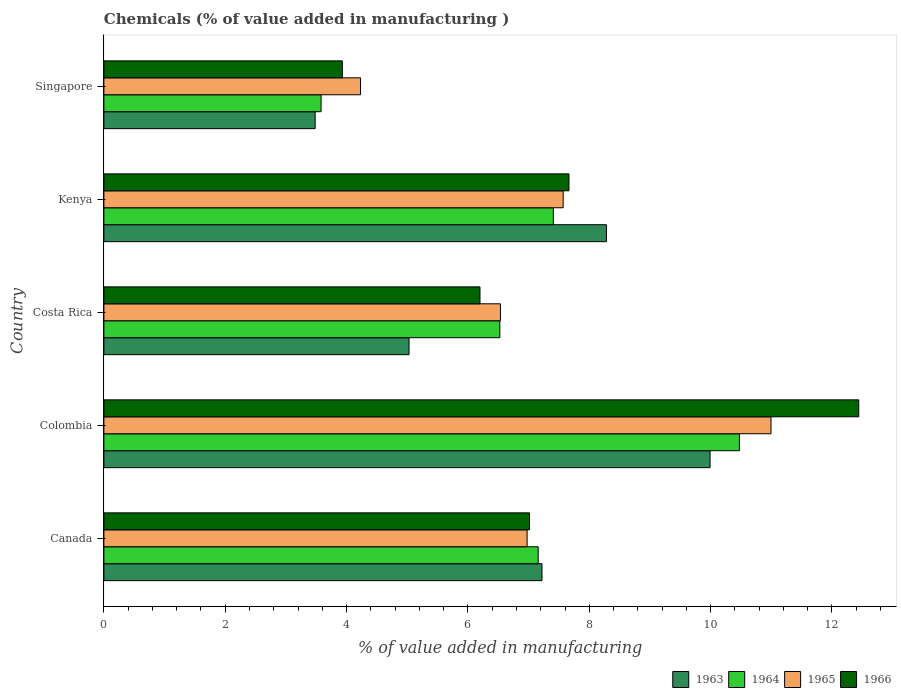Are the number of bars per tick equal to the number of legend labels?
Your response must be concise. Yes. What is the label of the 2nd group of bars from the top?
Give a very brief answer. Kenya. In how many cases, is the number of bars for a given country not equal to the number of legend labels?
Give a very brief answer. 0. What is the value added in manufacturing chemicals in 1966 in Singapore?
Offer a very short reply. 3.93. Across all countries, what is the maximum value added in manufacturing chemicals in 1966?
Provide a succinct answer. 12.44. Across all countries, what is the minimum value added in manufacturing chemicals in 1964?
Your answer should be very brief. 3.58. In which country was the value added in manufacturing chemicals in 1964 minimum?
Your response must be concise. Singapore. What is the total value added in manufacturing chemicals in 1963 in the graph?
Give a very brief answer. 34.01. What is the difference between the value added in manufacturing chemicals in 1963 in Canada and that in Kenya?
Offer a very short reply. -1.06. What is the difference between the value added in manufacturing chemicals in 1964 in Costa Rica and the value added in manufacturing chemicals in 1966 in Singapore?
Ensure brevity in your answer.  2.6. What is the average value added in manufacturing chemicals in 1965 per country?
Ensure brevity in your answer.  7.26. What is the difference between the value added in manufacturing chemicals in 1966 and value added in manufacturing chemicals in 1963 in Singapore?
Ensure brevity in your answer.  0.45. In how many countries, is the value added in manufacturing chemicals in 1963 greater than 6.8 %?
Offer a very short reply. 3. What is the ratio of the value added in manufacturing chemicals in 1964 in Canada to that in Colombia?
Offer a very short reply. 0.68. Is the difference between the value added in manufacturing chemicals in 1966 in Kenya and Singapore greater than the difference between the value added in manufacturing chemicals in 1963 in Kenya and Singapore?
Give a very brief answer. No. What is the difference between the highest and the second highest value added in manufacturing chemicals in 1965?
Your answer should be very brief. 3.43. What is the difference between the highest and the lowest value added in manufacturing chemicals in 1965?
Keep it short and to the point. 6.76. Is the sum of the value added in manufacturing chemicals in 1963 in Colombia and Singapore greater than the maximum value added in manufacturing chemicals in 1964 across all countries?
Give a very brief answer. Yes. Is it the case that in every country, the sum of the value added in manufacturing chemicals in 1965 and value added in manufacturing chemicals in 1966 is greater than the sum of value added in manufacturing chemicals in 1964 and value added in manufacturing chemicals in 1963?
Provide a short and direct response. No. What does the 4th bar from the top in Kenya represents?
Make the answer very short. 1963. What does the 4th bar from the bottom in Costa Rica represents?
Provide a short and direct response. 1966. How many bars are there?
Your answer should be compact. 20. Does the graph contain any zero values?
Provide a short and direct response. No. Does the graph contain grids?
Give a very brief answer. No. What is the title of the graph?
Offer a terse response. Chemicals (% of value added in manufacturing ). Does "2003" appear as one of the legend labels in the graph?
Keep it short and to the point. No. What is the label or title of the X-axis?
Offer a terse response. % of value added in manufacturing. What is the % of value added in manufacturing in 1963 in Canada?
Provide a short and direct response. 7.22. What is the % of value added in manufacturing of 1964 in Canada?
Ensure brevity in your answer.  7.16. What is the % of value added in manufacturing in 1965 in Canada?
Your response must be concise. 6.98. What is the % of value added in manufacturing in 1966 in Canada?
Make the answer very short. 7.01. What is the % of value added in manufacturing of 1963 in Colombia?
Give a very brief answer. 9.99. What is the % of value added in manufacturing of 1964 in Colombia?
Your answer should be compact. 10.47. What is the % of value added in manufacturing of 1965 in Colombia?
Your answer should be compact. 10.99. What is the % of value added in manufacturing in 1966 in Colombia?
Keep it short and to the point. 12.44. What is the % of value added in manufacturing in 1963 in Costa Rica?
Your response must be concise. 5.03. What is the % of value added in manufacturing in 1964 in Costa Rica?
Provide a short and direct response. 6.53. What is the % of value added in manufacturing in 1965 in Costa Rica?
Provide a short and direct response. 6.54. What is the % of value added in manufacturing in 1966 in Costa Rica?
Make the answer very short. 6.2. What is the % of value added in manufacturing of 1963 in Kenya?
Give a very brief answer. 8.28. What is the % of value added in manufacturing of 1964 in Kenya?
Make the answer very short. 7.41. What is the % of value added in manufacturing in 1965 in Kenya?
Your answer should be very brief. 7.57. What is the % of value added in manufacturing in 1966 in Kenya?
Make the answer very short. 7.67. What is the % of value added in manufacturing in 1963 in Singapore?
Ensure brevity in your answer.  3.48. What is the % of value added in manufacturing of 1964 in Singapore?
Provide a succinct answer. 3.58. What is the % of value added in manufacturing of 1965 in Singapore?
Give a very brief answer. 4.23. What is the % of value added in manufacturing of 1966 in Singapore?
Make the answer very short. 3.93. Across all countries, what is the maximum % of value added in manufacturing in 1963?
Provide a succinct answer. 9.99. Across all countries, what is the maximum % of value added in manufacturing of 1964?
Give a very brief answer. 10.47. Across all countries, what is the maximum % of value added in manufacturing of 1965?
Provide a succinct answer. 10.99. Across all countries, what is the maximum % of value added in manufacturing of 1966?
Provide a succinct answer. 12.44. Across all countries, what is the minimum % of value added in manufacturing of 1963?
Provide a short and direct response. 3.48. Across all countries, what is the minimum % of value added in manufacturing of 1964?
Provide a succinct answer. 3.58. Across all countries, what is the minimum % of value added in manufacturing of 1965?
Provide a succinct answer. 4.23. Across all countries, what is the minimum % of value added in manufacturing of 1966?
Provide a succinct answer. 3.93. What is the total % of value added in manufacturing in 1963 in the graph?
Keep it short and to the point. 34.01. What is the total % of value added in manufacturing in 1964 in the graph?
Give a very brief answer. 35.15. What is the total % of value added in manufacturing in 1965 in the graph?
Offer a terse response. 36.31. What is the total % of value added in manufacturing of 1966 in the graph?
Keep it short and to the point. 37.25. What is the difference between the % of value added in manufacturing in 1963 in Canada and that in Colombia?
Provide a succinct answer. -2.77. What is the difference between the % of value added in manufacturing of 1964 in Canada and that in Colombia?
Ensure brevity in your answer.  -3.32. What is the difference between the % of value added in manufacturing of 1965 in Canada and that in Colombia?
Provide a succinct answer. -4.02. What is the difference between the % of value added in manufacturing of 1966 in Canada and that in Colombia?
Your answer should be compact. -5.43. What is the difference between the % of value added in manufacturing of 1963 in Canada and that in Costa Rica?
Provide a short and direct response. 2.19. What is the difference between the % of value added in manufacturing of 1964 in Canada and that in Costa Rica?
Give a very brief answer. 0.63. What is the difference between the % of value added in manufacturing of 1965 in Canada and that in Costa Rica?
Keep it short and to the point. 0.44. What is the difference between the % of value added in manufacturing in 1966 in Canada and that in Costa Rica?
Offer a terse response. 0.82. What is the difference between the % of value added in manufacturing of 1963 in Canada and that in Kenya?
Make the answer very short. -1.06. What is the difference between the % of value added in manufacturing in 1964 in Canada and that in Kenya?
Provide a short and direct response. -0.25. What is the difference between the % of value added in manufacturing in 1965 in Canada and that in Kenya?
Ensure brevity in your answer.  -0.59. What is the difference between the % of value added in manufacturing of 1966 in Canada and that in Kenya?
Your response must be concise. -0.65. What is the difference between the % of value added in manufacturing of 1963 in Canada and that in Singapore?
Provide a succinct answer. 3.74. What is the difference between the % of value added in manufacturing of 1964 in Canada and that in Singapore?
Give a very brief answer. 3.58. What is the difference between the % of value added in manufacturing of 1965 in Canada and that in Singapore?
Make the answer very short. 2.75. What is the difference between the % of value added in manufacturing in 1966 in Canada and that in Singapore?
Your answer should be very brief. 3.08. What is the difference between the % of value added in manufacturing in 1963 in Colombia and that in Costa Rica?
Make the answer very short. 4.96. What is the difference between the % of value added in manufacturing of 1964 in Colombia and that in Costa Rica?
Your response must be concise. 3.95. What is the difference between the % of value added in manufacturing in 1965 in Colombia and that in Costa Rica?
Ensure brevity in your answer.  4.46. What is the difference between the % of value added in manufacturing of 1966 in Colombia and that in Costa Rica?
Offer a very short reply. 6.24. What is the difference between the % of value added in manufacturing of 1963 in Colombia and that in Kenya?
Your answer should be compact. 1.71. What is the difference between the % of value added in manufacturing in 1964 in Colombia and that in Kenya?
Provide a short and direct response. 3.07. What is the difference between the % of value added in manufacturing of 1965 in Colombia and that in Kenya?
Make the answer very short. 3.43. What is the difference between the % of value added in manufacturing of 1966 in Colombia and that in Kenya?
Offer a very short reply. 4.78. What is the difference between the % of value added in manufacturing in 1963 in Colombia and that in Singapore?
Offer a terse response. 6.51. What is the difference between the % of value added in manufacturing in 1964 in Colombia and that in Singapore?
Give a very brief answer. 6.89. What is the difference between the % of value added in manufacturing of 1965 in Colombia and that in Singapore?
Provide a succinct answer. 6.76. What is the difference between the % of value added in manufacturing of 1966 in Colombia and that in Singapore?
Provide a succinct answer. 8.51. What is the difference between the % of value added in manufacturing in 1963 in Costa Rica and that in Kenya?
Give a very brief answer. -3.25. What is the difference between the % of value added in manufacturing in 1964 in Costa Rica and that in Kenya?
Provide a succinct answer. -0.88. What is the difference between the % of value added in manufacturing of 1965 in Costa Rica and that in Kenya?
Provide a short and direct response. -1.03. What is the difference between the % of value added in manufacturing in 1966 in Costa Rica and that in Kenya?
Give a very brief answer. -1.47. What is the difference between the % of value added in manufacturing in 1963 in Costa Rica and that in Singapore?
Ensure brevity in your answer.  1.55. What is the difference between the % of value added in manufacturing of 1964 in Costa Rica and that in Singapore?
Provide a short and direct response. 2.95. What is the difference between the % of value added in manufacturing in 1965 in Costa Rica and that in Singapore?
Ensure brevity in your answer.  2.31. What is the difference between the % of value added in manufacturing in 1966 in Costa Rica and that in Singapore?
Keep it short and to the point. 2.27. What is the difference between the % of value added in manufacturing of 1963 in Kenya and that in Singapore?
Ensure brevity in your answer.  4.8. What is the difference between the % of value added in manufacturing in 1964 in Kenya and that in Singapore?
Offer a terse response. 3.83. What is the difference between the % of value added in manufacturing in 1965 in Kenya and that in Singapore?
Offer a terse response. 3.34. What is the difference between the % of value added in manufacturing of 1966 in Kenya and that in Singapore?
Make the answer very short. 3.74. What is the difference between the % of value added in manufacturing in 1963 in Canada and the % of value added in manufacturing in 1964 in Colombia?
Keep it short and to the point. -3.25. What is the difference between the % of value added in manufacturing of 1963 in Canada and the % of value added in manufacturing of 1965 in Colombia?
Offer a very short reply. -3.77. What is the difference between the % of value added in manufacturing in 1963 in Canada and the % of value added in manufacturing in 1966 in Colombia?
Your response must be concise. -5.22. What is the difference between the % of value added in manufacturing of 1964 in Canada and the % of value added in manufacturing of 1965 in Colombia?
Keep it short and to the point. -3.84. What is the difference between the % of value added in manufacturing in 1964 in Canada and the % of value added in manufacturing in 1966 in Colombia?
Your response must be concise. -5.28. What is the difference between the % of value added in manufacturing of 1965 in Canada and the % of value added in manufacturing of 1966 in Colombia?
Keep it short and to the point. -5.47. What is the difference between the % of value added in manufacturing of 1963 in Canada and the % of value added in manufacturing of 1964 in Costa Rica?
Your answer should be compact. 0.69. What is the difference between the % of value added in manufacturing in 1963 in Canada and the % of value added in manufacturing in 1965 in Costa Rica?
Your answer should be very brief. 0.68. What is the difference between the % of value added in manufacturing of 1963 in Canada and the % of value added in manufacturing of 1966 in Costa Rica?
Your answer should be very brief. 1.02. What is the difference between the % of value added in manufacturing in 1964 in Canada and the % of value added in manufacturing in 1965 in Costa Rica?
Your answer should be very brief. 0.62. What is the difference between the % of value added in manufacturing in 1964 in Canada and the % of value added in manufacturing in 1966 in Costa Rica?
Offer a very short reply. 0.96. What is the difference between the % of value added in manufacturing in 1965 in Canada and the % of value added in manufacturing in 1966 in Costa Rica?
Offer a very short reply. 0.78. What is the difference between the % of value added in manufacturing of 1963 in Canada and the % of value added in manufacturing of 1964 in Kenya?
Provide a succinct answer. -0.19. What is the difference between the % of value added in manufacturing in 1963 in Canada and the % of value added in manufacturing in 1965 in Kenya?
Offer a terse response. -0.35. What is the difference between the % of value added in manufacturing in 1963 in Canada and the % of value added in manufacturing in 1966 in Kenya?
Offer a very short reply. -0.44. What is the difference between the % of value added in manufacturing in 1964 in Canada and the % of value added in manufacturing in 1965 in Kenya?
Give a very brief answer. -0.41. What is the difference between the % of value added in manufacturing in 1964 in Canada and the % of value added in manufacturing in 1966 in Kenya?
Ensure brevity in your answer.  -0.51. What is the difference between the % of value added in manufacturing of 1965 in Canada and the % of value added in manufacturing of 1966 in Kenya?
Keep it short and to the point. -0.69. What is the difference between the % of value added in manufacturing of 1963 in Canada and the % of value added in manufacturing of 1964 in Singapore?
Offer a terse response. 3.64. What is the difference between the % of value added in manufacturing of 1963 in Canada and the % of value added in manufacturing of 1965 in Singapore?
Your answer should be very brief. 2.99. What is the difference between the % of value added in manufacturing in 1963 in Canada and the % of value added in manufacturing in 1966 in Singapore?
Provide a succinct answer. 3.29. What is the difference between the % of value added in manufacturing in 1964 in Canada and the % of value added in manufacturing in 1965 in Singapore?
Give a very brief answer. 2.93. What is the difference between the % of value added in manufacturing in 1964 in Canada and the % of value added in manufacturing in 1966 in Singapore?
Provide a short and direct response. 3.23. What is the difference between the % of value added in manufacturing of 1965 in Canada and the % of value added in manufacturing of 1966 in Singapore?
Provide a succinct answer. 3.05. What is the difference between the % of value added in manufacturing of 1963 in Colombia and the % of value added in manufacturing of 1964 in Costa Rica?
Your answer should be compact. 3.47. What is the difference between the % of value added in manufacturing of 1963 in Colombia and the % of value added in manufacturing of 1965 in Costa Rica?
Provide a succinct answer. 3.46. What is the difference between the % of value added in manufacturing in 1963 in Colombia and the % of value added in manufacturing in 1966 in Costa Rica?
Offer a terse response. 3.79. What is the difference between the % of value added in manufacturing of 1964 in Colombia and the % of value added in manufacturing of 1965 in Costa Rica?
Give a very brief answer. 3.94. What is the difference between the % of value added in manufacturing in 1964 in Colombia and the % of value added in manufacturing in 1966 in Costa Rica?
Make the answer very short. 4.28. What is the difference between the % of value added in manufacturing of 1965 in Colombia and the % of value added in manufacturing of 1966 in Costa Rica?
Keep it short and to the point. 4.8. What is the difference between the % of value added in manufacturing of 1963 in Colombia and the % of value added in manufacturing of 1964 in Kenya?
Your answer should be very brief. 2.58. What is the difference between the % of value added in manufacturing of 1963 in Colombia and the % of value added in manufacturing of 1965 in Kenya?
Your answer should be compact. 2.42. What is the difference between the % of value added in manufacturing in 1963 in Colombia and the % of value added in manufacturing in 1966 in Kenya?
Your answer should be very brief. 2.33. What is the difference between the % of value added in manufacturing in 1964 in Colombia and the % of value added in manufacturing in 1965 in Kenya?
Give a very brief answer. 2.9. What is the difference between the % of value added in manufacturing of 1964 in Colombia and the % of value added in manufacturing of 1966 in Kenya?
Provide a succinct answer. 2.81. What is the difference between the % of value added in manufacturing in 1965 in Colombia and the % of value added in manufacturing in 1966 in Kenya?
Offer a terse response. 3.33. What is the difference between the % of value added in manufacturing in 1963 in Colombia and the % of value added in manufacturing in 1964 in Singapore?
Provide a short and direct response. 6.41. What is the difference between the % of value added in manufacturing of 1963 in Colombia and the % of value added in manufacturing of 1965 in Singapore?
Your response must be concise. 5.76. What is the difference between the % of value added in manufacturing in 1963 in Colombia and the % of value added in manufacturing in 1966 in Singapore?
Your answer should be very brief. 6.06. What is the difference between the % of value added in manufacturing of 1964 in Colombia and the % of value added in manufacturing of 1965 in Singapore?
Your answer should be compact. 6.24. What is the difference between the % of value added in manufacturing in 1964 in Colombia and the % of value added in manufacturing in 1966 in Singapore?
Provide a succinct answer. 6.54. What is the difference between the % of value added in manufacturing of 1965 in Colombia and the % of value added in manufacturing of 1966 in Singapore?
Your response must be concise. 7.07. What is the difference between the % of value added in manufacturing of 1963 in Costa Rica and the % of value added in manufacturing of 1964 in Kenya?
Ensure brevity in your answer.  -2.38. What is the difference between the % of value added in manufacturing in 1963 in Costa Rica and the % of value added in manufacturing in 1965 in Kenya?
Make the answer very short. -2.54. What is the difference between the % of value added in manufacturing of 1963 in Costa Rica and the % of value added in manufacturing of 1966 in Kenya?
Your response must be concise. -2.64. What is the difference between the % of value added in manufacturing in 1964 in Costa Rica and the % of value added in manufacturing in 1965 in Kenya?
Ensure brevity in your answer.  -1.04. What is the difference between the % of value added in manufacturing in 1964 in Costa Rica and the % of value added in manufacturing in 1966 in Kenya?
Offer a terse response. -1.14. What is the difference between the % of value added in manufacturing in 1965 in Costa Rica and the % of value added in manufacturing in 1966 in Kenya?
Provide a short and direct response. -1.13. What is the difference between the % of value added in manufacturing in 1963 in Costa Rica and the % of value added in manufacturing in 1964 in Singapore?
Make the answer very short. 1.45. What is the difference between the % of value added in manufacturing of 1963 in Costa Rica and the % of value added in manufacturing of 1965 in Singapore?
Your response must be concise. 0.8. What is the difference between the % of value added in manufacturing in 1963 in Costa Rica and the % of value added in manufacturing in 1966 in Singapore?
Ensure brevity in your answer.  1.1. What is the difference between the % of value added in manufacturing of 1964 in Costa Rica and the % of value added in manufacturing of 1965 in Singapore?
Offer a very short reply. 2.3. What is the difference between the % of value added in manufacturing in 1964 in Costa Rica and the % of value added in manufacturing in 1966 in Singapore?
Your response must be concise. 2.6. What is the difference between the % of value added in manufacturing of 1965 in Costa Rica and the % of value added in manufacturing of 1966 in Singapore?
Offer a very short reply. 2.61. What is the difference between the % of value added in manufacturing of 1963 in Kenya and the % of value added in manufacturing of 1964 in Singapore?
Ensure brevity in your answer.  4.7. What is the difference between the % of value added in manufacturing in 1963 in Kenya and the % of value added in manufacturing in 1965 in Singapore?
Offer a very short reply. 4.05. What is the difference between the % of value added in manufacturing of 1963 in Kenya and the % of value added in manufacturing of 1966 in Singapore?
Give a very brief answer. 4.35. What is the difference between the % of value added in manufacturing in 1964 in Kenya and the % of value added in manufacturing in 1965 in Singapore?
Your answer should be very brief. 3.18. What is the difference between the % of value added in manufacturing of 1964 in Kenya and the % of value added in manufacturing of 1966 in Singapore?
Make the answer very short. 3.48. What is the difference between the % of value added in manufacturing of 1965 in Kenya and the % of value added in manufacturing of 1966 in Singapore?
Provide a short and direct response. 3.64. What is the average % of value added in manufacturing of 1963 per country?
Make the answer very short. 6.8. What is the average % of value added in manufacturing in 1964 per country?
Your answer should be very brief. 7.03. What is the average % of value added in manufacturing of 1965 per country?
Ensure brevity in your answer.  7.26. What is the average % of value added in manufacturing of 1966 per country?
Your response must be concise. 7.45. What is the difference between the % of value added in manufacturing of 1963 and % of value added in manufacturing of 1964 in Canada?
Give a very brief answer. 0.06. What is the difference between the % of value added in manufacturing in 1963 and % of value added in manufacturing in 1965 in Canada?
Keep it short and to the point. 0.25. What is the difference between the % of value added in manufacturing of 1963 and % of value added in manufacturing of 1966 in Canada?
Provide a succinct answer. 0.21. What is the difference between the % of value added in manufacturing in 1964 and % of value added in manufacturing in 1965 in Canada?
Give a very brief answer. 0.18. What is the difference between the % of value added in manufacturing in 1964 and % of value added in manufacturing in 1966 in Canada?
Your answer should be compact. 0.14. What is the difference between the % of value added in manufacturing in 1965 and % of value added in manufacturing in 1966 in Canada?
Offer a very short reply. -0.04. What is the difference between the % of value added in manufacturing of 1963 and % of value added in manufacturing of 1964 in Colombia?
Provide a succinct answer. -0.48. What is the difference between the % of value added in manufacturing of 1963 and % of value added in manufacturing of 1965 in Colombia?
Keep it short and to the point. -1. What is the difference between the % of value added in manufacturing in 1963 and % of value added in manufacturing in 1966 in Colombia?
Your answer should be very brief. -2.45. What is the difference between the % of value added in manufacturing in 1964 and % of value added in manufacturing in 1965 in Colombia?
Offer a terse response. -0.52. What is the difference between the % of value added in manufacturing of 1964 and % of value added in manufacturing of 1966 in Colombia?
Provide a succinct answer. -1.97. What is the difference between the % of value added in manufacturing in 1965 and % of value added in manufacturing in 1966 in Colombia?
Offer a terse response. -1.45. What is the difference between the % of value added in manufacturing in 1963 and % of value added in manufacturing in 1964 in Costa Rica?
Your response must be concise. -1.5. What is the difference between the % of value added in manufacturing of 1963 and % of value added in manufacturing of 1965 in Costa Rica?
Offer a very short reply. -1.51. What is the difference between the % of value added in manufacturing in 1963 and % of value added in manufacturing in 1966 in Costa Rica?
Give a very brief answer. -1.17. What is the difference between the % of value added in manufacturing in 1964 and % of value added in manufacturing in 1965 in Costa Rica?
Make the answer very short. -0.01. What is the difference between the % of value added in manufacturing in 1964 and % of value added in manufacturing in 1966 in Costa Rica?
Offer a terse response. 0.33. What is the difference between the % of value added in manufacturing of 1965 and % of value added in manufacturing of 1966 in Costa Rica?
Provide a succinct answer. 0.34. What is the difference between the % of value added in manufacturing in 1963 and % of value added in manufacturing in 1964 in Kenya?
Your answer should be very brief. 0.87. What is the difference between the % of value added in manufacturing in 1963 and % of value added in manufacturing in 1965 in Kenya?
Your response must be concise. 0.71. What is the difference between the % of value added in manufacturing in 1963 and % of value added in manufacturing in 1966 in Kenya?
Provide a succinct answer. 0.62. What is the difference between the % of value added in manufacturing in 1964 and % of value added in manufacturing in 1965 in Kenya?
Ensure brevity in your answer.  -0.16. What is the difference between the % of value added in manufacturing of 1964 and % of value added in manufacturing of 1966 in Kenya?
Your response must be concise. -0.26. What is the difference between the % of value added in manufacturing of 1965 and % of value added in manufacturing of 1966 in Kenya?
Provide a short and direct response. -0.1. What is the difference between the % of value added in manufacturing of 1963 and % of value added in manufacturing of 1964 in Singapore?
Your response must be concise. -0.1. What is the difference between the % of value added in manufacturing in 1963 and % of value added in manufacturing in 1965 in Singapore?
Keep it short and to the point. -0.75. What is the difference between the % of value added in manufacturing in 1963 and % of value added in manufacturing in 1966 in Singapore?
Give a very brief answer. -0.45. What is the difference between the % of value added in manufacturing in 1964 and % of value added in manufacturing in 1965 in Singapore?
Offer a terse response. -0.65. What is the difference between the % of value added in manufacturing of 1964 and % of value added in manufacturing of 1966 in Singapore?
Your response must be concise. -0.35. What is the difference between the % of value added in manufacturing of 1965 and % of value added in manufacturing of 1966 in Singapore?
Your response must be concise. 0.3. What is the ratio of the % of value added in manufacturing in 1963 in Canada to that in Colombia?
Provide a short and direct response. 0.72. What is the ratio of the % of value added in manufacturing of 1964 in Canada to that in Colombia?
Your response must be concise. 0.68. What is the ratio of the % of value added in manufacturing in 1965 in Canada to that in Colombia?
Offer a terse response. 0.63. What is the ratio of the % of value added in manufacturing of 1966 in Canada to that in Colombia?
Offer a very short reply. 0.56. What is the ratio of the % of value added in manufacturing in 1963 in Canada to that in Costa Rica?
Your answer should be very brief. 1.44. What is the ratio of the % of value added in manufacturing of 1964 in Canada to that in Costa Rica?
Ensure brevity in your answer.  1.1. What is the ratio of the % of value added in manufacturing in 1965 in Canada to that in Costa Rica?
Your answer should be very brief. 1.07. What is the ratio of the % of value added in manufacturing of 1966 in Canada to that in Costa Rica?
Offer a terse response. 1.13. What is the ratio of the % of value added in manufacturing of 1963 in Canada to that in Kenya?
Offer a terse response. 0.87. What is the ratio of the % of value added in manufacturing of 1964 in Canada to that in Kenya?
Offer a very short reply. 0.97. What is the ratio of the % of value added in manufacturing of 1965 in Canada to that in Kenya?
Ensure brevity in your answer.  0.92. What is the ratio of the % of value added in manufacturing of 1966 in Canada to that in Kenya?
Offer a very short reply. 0.92. What is the ratio of the % of value added in manufacturing of 1963 in Canada to that in Singapore?
Keep it short and to the point. 2.07. What is the ratio of the % of value added in manufacturing of 1964 in Canada to that in Singapore?
Offer a very short reply. 2. What is the ratio of the % of value added in manufacturing of 1965 in Canada to that in Singapore?
Keep it short and to the point. 1.65. What is the ratio of the % of value added in manufacturing in 1966 in Canada to that in Singapore?
Your response must be concise. 1.78. What is the ratio of the % of value added in manufacturing of 1963 in Colombia to that in Costa Rica?
Offer a very short reply. 1.99. What is the ratio of the % of value added in manufacturing of 1964 in Colombia to that in Costa Rica?
Give a very brief answer. 1.61. What is the ratio of the % of value added in manufacturing in 1965 in Colombia to that in Costa Rica?
Provide a succinct answer. 1.68. What is the ratio of the % of value added in manufacturing in 1966 in Colombia to that in Costa Rica?
Keep it short and to the point. 2.01. What is the ratio of the % of value added in manufacturing of 1963 in Colombia to that in Kenya?
Make the answer very short. 1.21. What is the ratio of the % of value added in manufacturing of 1964 in Colombia to that in Kenya?
Your answer should be compact. 1.41. What is the ratio of the % of value added in manufacturing of 1965 in Colombia to that in Kenya?
Offer a terse response. 1.45. What is the ratio of the % of value added in manufacturing of 1966 in Colombia to that in Kenya?
Keep it short and to the point. 1.62. What is the ratio of the % of value added in manufacturing in 1963 in Colombia to that in Singapore?
Make the answer very short. 2.87. What is the ratio of the % of value added in manufacturing in 1964 in Colombia to that in Singapore?
Provide a short and direct response. 2.93. What is the ratio of the % of value added in manufacturing of 1965 in Colombia to that in Singapore?
Your answer should be compact. 2.6. What is the ratio of the % of value added in manufacturing of 1966 in Colombia to that in Singapore?
Your answer should be compact. 3.17. What is the ratio of the % of value added in manufacturing of 1963 in Costa Rica to that in Kenya?
Give a very brief answer. 0.61. What is the ratio of the % of value added in manufacturing in 1964 in Costa Rica to that in Kenya?
Make the answer very short. 0.88. What is the ratio of the % of value added in manufacturing of 1965 in Costa Rica to that in Kenya?
Provide a short and direct response. 0.86. What is the ratio of the % of value added in manufacturing of 1966 in Costa Rica to that in Kenya?
Make the answer very short. 0.81. What is the ratio of the % of value added in manufacturing in 1963 in Costa Rica to that in Singapore?
Your answer should be compact. 1.44. What is the ratio of the % of value added in manufacturing of 1964 in Costa Rica to that in Singapore?
Offer a terse response. 1.82. What is the ratio of the % of value added in manufacturing of 1965 in Costa Rica to that in Singapore?
Your answer should be very brief. 1.55. What is the ratio of the % of value added in manufacturing of 1966 in Costa Rica to that in Singapore?
Your response must be concise. 1.58. What is the ratio of the % of value added in manufacturing of 1963 in Kenya to that in Singapore?
Make the answer very short. 2.38. What is the ratio of the % of value added in manufacturing of 1964 in Kenya to that in Singapore?
Give a very brief answer. 2.07. What is the ratio of the % of value added in manufacturing in 1965 in Kenya to that in Singapore?
Make the answer very short. 1.79. What is the ratio of the % of value added in manufacturing of 1966 in Kenya to that in Singapore?
Your response must be concise. 1.95. What is the difference between the highest and the second highest % of value added in manufacturing in 1963?
Provide a short and direct response. 1.71. What is the difference between the highest and the second highest % of value added in manufacturing of 1964?
Your response must be concise. 3.07. What is the difference between the highest and the second highest % of value added in manufacturing of 1965?
Offer a terse response. 3.43. What is the difference between the highest and the second highest % of value added in manufacturing in 1966?
Keep it short and to the point. 4.78. What is the difference between the highest and the lowest % of value added in manufacturing of 1963?
Provide a short and direct response. 6.51. What is the difference between the highest and the lowest % of value added in manufacturing of 1964?
Provide a succinct answer. 6.89. What is the difference between the highest and the lowest % of value added in manufacturing in 1965?
Provide a succinct answer. 6.76. What is the difference between the highest and the lowest % of value added in manufacturing in 1966?
Keep it short and to the point. 8.51. 